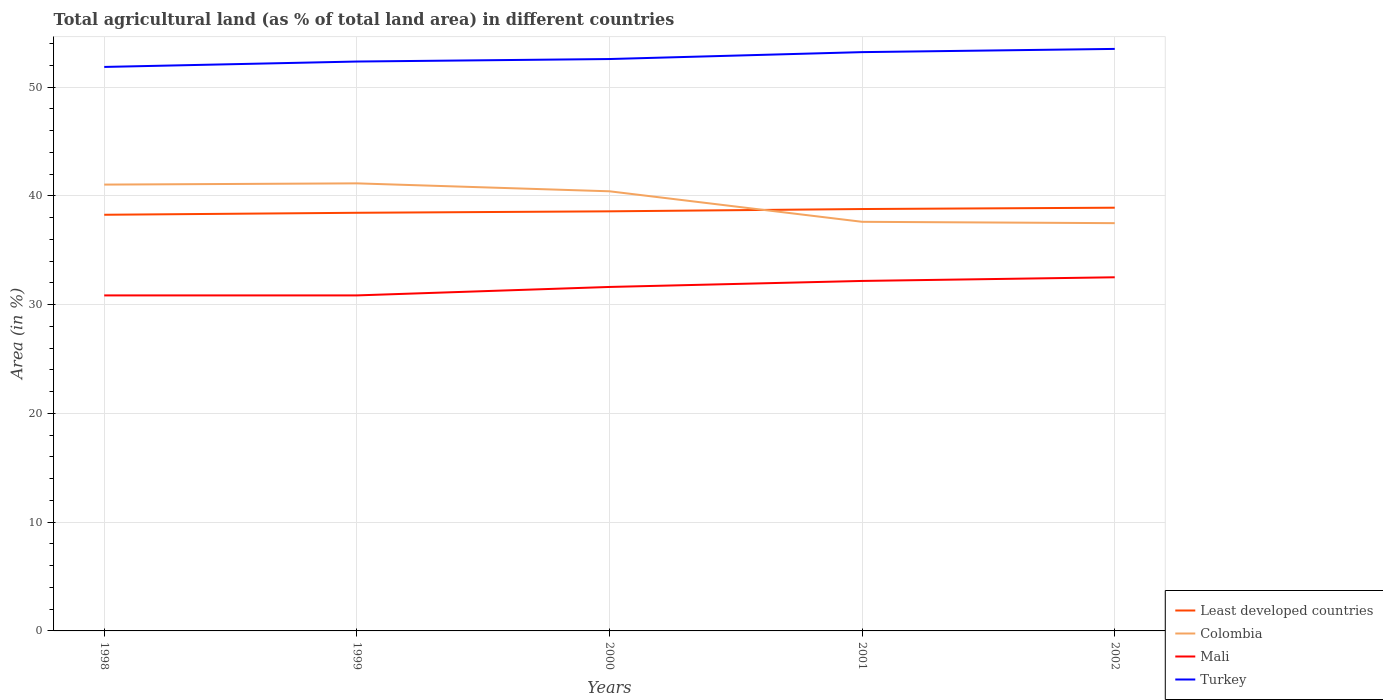Does the line corresponding to Mali intersect with the line corresponding to Least developed countries?
Your answer should be compact. No. Is the number of lines equal to the number of legend labels?
Offer a terse response. Yes. Across all years, what is the maximum percentage of agricultural land in Mali?
Your answer should be very brief. 30.86. In which year was the percentage of agricultural land in Turkey maximum?
Offer a terse response. 1998. What is the total percentage of agricultural land in Least developed countries in the graph?
Provide a succinct answer. -0.32. What is the difference between the highest and the second highest percentage of agricultural land in Least developed countries?
Offer a very short reply. 0.65. How many lines are there?
Provide a succinct answer. 4. How many years are there in the graph?
Your answer should be compact. 5. What is the difference between two consecutive major ticks on the Y-axis?
Offer a very short reply. 10. Does the graph contain any zero values?
Offer a very short reply. No. Does the graph contain grids?
Provide a succinct answer. Yes. Where does the legend appear in the graph?
Offer a very short reply. Bottom right. How many legend labels are there?
Your answer should be very brief. 4. How are the legend labels stacked?
Give a very brief answer. Vertical. What is the title of the graph?
Keep it short and to the point. Total agricultural land (as % of total land area) in different countries. What is the label or title of the Y-axis?
Offer a very short reply. Area (in %). What is the Area (in %) of Least developed countries in 1998?
Provide a short and direct response. 38.27. What is the Area (in %) of Colombia in 1998?
Offer a very short reply. 41.05. What is the Area (in %) in Mali in 1998?
Give a very brief answer. 30.86. What is the Area (in %) in Turkey in 1998?
Make the answer very short. 51.87. What is the Area (in %) of Least developed countries in 1999?
Your response must be concise. 38.46. What is the Area (in %) in Colombia in 1999?
Ensure brevity in your answer.  41.16. What is the Area (in %) in Mali in 1999?
Provide a short and direct response. 30.86. What is the Area (in %) of Turkey in 1999?
Keep it short and to the point. 52.37. What is the Area (in %) in Least developed countries in 2000?
Your answer should be compact. 38.59. What is the Area (in %) of Colombia in 2000?
Your response must be concise. 40.43. What is the Area (in %) of Mali in 2000?
Offer a very short reply. 31.63. What is the Area (in %) in Turkey in 2000?
Ensure brevity in your answer.  52.6. What is the Area (in %) in Least developed countries in 2001?
Offer a terse response. 38.8. What is the Area (in %) in Colombia in 2001?
Your answer should be very brief. 37.63. What is the Area (in %) of Mali in 2001?
Your answer should be compact. 32.19. What is the Area (in %) in Turkey in 2001?
Your response must be concise. 53.23. What is the Area (in %) in Least developed countries in 2002?
Provide a short and direct response. 38.92. What is the Area (in %) of Colombia in 2002?
Keep it short and to the point. 37.5. What is the Area (in %) in Mali in 2002?
Your answer should be compact. 32.52. What is the Area (in %) of Turkey in 2002?
Offer a terse response. 53.53. Across all years, what is the maximum Area (in %) of Least developed countries?
Offer a terse response. 38.92. Across all years, what is the maximum Area (in %) in Colombia?
Your answer should be compact. 41.16. Across all years, what is the maximum Area (in %) in Mali?
Your answer should be very brief. 32.52. Across all years, what is the maximum Area (in %) of Turkey?
Keep it short and to the point. 53.53. Across all years, what is the minimum Area (in %) of Least developed countries?
Keep it short and to the point. 38.27. Across all years, what is the minimum Area (in %) of Colombia?
Keep it short and to the point. 37.5. Across all years, what is the minimum Area (in %) of Mali?
Your response must be concise. 30.86. Across all years, what is the minimum Area (in %) in Turkey?
Your response must be concise. 51.87. What is the total Area (in %) in Least developed countries in the graph?
Give a very brief answer. 193.04. What is the total Area (in %) of Colombia in the graph?
Offer a terse response. 197.77. What is the total Area (in %) of Mali in the graph?
Your answer should be very brief. 158.06. What is the total Area (in %) of Turkey in the graph?
Offer a terse response. 263.59. What is the difference between the Area (in %) of Least developed countries in 1998 and that in 1999?
Keep it short and to the point. -0.18. What is the difference between the Area (in %) of Colombia in 1998 and that in 1999?
Provide a succinct answer. -0.11. What is the difference between the Area (in %) of Mali in 1998 and that in 1999?
Offer a very short reply. 0. What is the difference between the Area (in %) of Turkey in 1998 and that in 1999?
Your response must be concise. -0.5. What is the difference between the Area (in %) of Least developed countries in 1998 and that in 2000?
Provide a short and direct response. -0.32. What is the difference between the Area (in %) of Colombia in 1998 and that in 2000?
Ensure brevity in your answer.  0.62. What is the difference between the Area (in %) of Mali in 1998 and that in 2000?
Offer a very short reply. -0.78. What is the difference between the Area (in %) of Turkey in 1998 and that in 2000?
Keep it short and to the point. -0.73. What is the difference between the Area (in %) in Least developed countries in 1998 and that in 2001?
Your answer should be very brief. -0.53. What is the difference between the Area (in %) of Colombia in 1998 and that in 2001?
Your response must be concise. 3.42. What is the difference between the Area (in %) of Mali in 1998 and that in 2001?
Your answer should be compact. -1.33. What is the difference between the Area (in %) in Turkey in 1998 and that in 2001?
Offer a very short reply. -1.36. What is the difference between the Area (in %) of Least developed countries in 1998 and that in 2002?
Your answer should be very brief. -0.65. What is the difference between the Area (in %) of Colombia in 1998 and that in 2002?
Your answer should be very brief. 3.55. What is the difference between the Area (in %) of Mali in 1998 and that in 2002?
Offer a very short reply. -1.67. What is the difference between the Area (in %) in Turkey in 1998 and that in 2002?
Ensure brevity in your answer.  -1.66. What is the difference between the Area (in %) of Least developed countries in 1999 and that in 2000?
Give a very brief answer. -0.13. What is the difference between the Area (in %) of Colombia in 1999 and that in 2000?
Your answer should be compact. 0.73. What is the difference between the Area (in %) of Mali in 1999 and that in 2000?
Make the answer very short. -0.78. What is the difference between the Area (in %) of Turkey in 1999 and that in 2000?
Offer a terse response. -0.23. What is the difference between the Area (in %) in Least developed countries in 1999 and that in 2001?
Your response must be concise. -0.34. What is the difference between the Area (in %) in Colombia in 1999 and that in 2001?
Offer a terse response. 3.54. What is the difference between the Area (in %) of Mali in 1999 and that in 2001?
Your response must be concise. -1.33. What is the difference between the Area (in %) in Turkey in 1999 and that in 2001?
Give a very brief answer. -0.87. What is the difference between the Area (in %) of Least developed countries in 1999 and that in 2002?
Your answer should be compact. -0.47. What is the difference between the Area (in %) in Colombia in 1999 and that in 2002?
Your response must be concise. 3.66. What is the difference between the Area (in %) in Mali in 1999 and that in 2002?
Provide a succinct answer. -1.67. What is the difference between the Area (in %) of Turkey in 1999 and that in 2002?
Make the answer very short. -1.16. What is the difference between the Area (in %) of Least developed countries in 2000 and that in 2001?
Provide a succinct answer. -0.21. What is the difference between the Area (in %) in Colombia in 2000 and that in 2001?
Provide a succinct answer. 2.81. What is the difference between the Area (in %) of Mali in 2000 and that in 2001?
Provide a succinct answer. -0.55. What is the difference between the Area (in %) of Turkey in 2000 and that in 2001?
Give a very brief answer. -0.64. What is the difference between the Area (in %) in Least developed countries in 2000 and that in 2002?
Offer a very short reply. -0.33. What is the difference between the Area (in %) in Colombia in 2000 and that in 2002?
Offer a very short reply. 2.93. What is the difference between the Area (in %) in Mali in 2000 and that in 2002?
Make the answer very short. -0.89. What is the difference between the Area (in %) of Turkey in 2000 and that in 2002?
Make the answer very short. -0.93. What is the difference between the Area (in %) in Least developed countries in 2001 and that in 2002?
Ensure brevity in your answer.  -0.12. What is the difference between the Area (in %) of Colombia in 2001 and that in 2002?
Provide a short and direct response. 0.12. What is the difference between the Area (in %) of Mali in 2001 and that in 2002?
Give a very brief answer. -0.34. What is the difference between the Area (in %) in Turkey in 2001 and that in 2002?
Your answer should be very brief. -0.3. What is the difference between the Area (in %) of Least developed countries in 1998 and the Area (in %) of Colombia in 1999?
Provide a succinct answer. -2.89. What is the difference between the Area (in %) of Least developed countries in 1998 and the Area (in %) of Mali in 1999?
Your answer should be compact. 7.42. What is the difference between the Area (in %) of Least developed countries in 1998 and the Area (in %) of Turkey in 1999?
Keep it short and to the point. -14.09. What is the difference between the Area (in %) in Colombia in 1998 and the Area (in %) in Mali in 1999?
Provide a succinct answer. 10.19. What is the difference between the Area (in %) in Colombia in 1998 and the Area (in %) in Turkey in 1999?
Make the answer very short. -11.32. What is the difference between the Area (in %) in Mali in 1998 and the Area (in %) in Turkey in 1999?
Provide a short and direct response. -21.51. What is the difference between the Area (in %) in Least developed countries in 1998 and the Area (in %) in Colombia in 2000?
Your response must be concise. -2.16. What is the difference between the Area (in %) of Least developed countries in 1998 and the Area (in %) of Mali in 2000?
Keep it short and to the point. 6.64. What is the difference between the Area (in %) in Least developed countries in 1998 and the Area (in %) in Turkey in 2000?
Offer a very short reply. -14.32. What is the difference between the Area (in %) in Colombia in 1998 and the Area (in %) in Mali in 2000?
Keep it short and to the point. 9.41. What is the difference between the Area (in %) in Colombia in 1998 and the Area (in %) in Turkey in 2000?
Ensure brevity in your answer.  -11.55. What is the difference between the Area (in %) in Mali in 1998 and the Area (in %) in Turkey in 2000?
Ensure brevity in your answer.  -21.74. What is the difference between the Area (in %) of Least developed countries in 1998 and the Area (in %) of Colombia in 2001?
Give a very brief answer. 0.65. What is the difference between the Area (in %) in Least developed countries in 1998 and the Area (in %) in Mali in 2001?
Ensure brevity in your answer.  6.09. What is the difference between the Area (in %) of Least developed countries in 1998 and the Area (in %) of Turkey in 2001?
Ensure brevity in your answer.  -14.96. What is the difference between the Area (in %) of Colombia in 1998 and the Area (in %) of Mali in 2001?
Provide a succinct answer. 8.86. What is the difference between the Area (in %) of Colombia in 1998 and the Area (in %) of Turkey in 2001?
Give a very brief answer. -12.18. What is the difference between the Area (in %) of Mali in 1998 and the Area (in %) of Turkey in 2001?
Provide a short and direct response. -22.37. What is the difference between the Area (in %) of Least developed countries in 1998 and the Area (in %) of Colombia in 2002?
Offer a terse response. 0.77. What is the difference between the Area (in %) of Least developed countries in 1998 and the Area (in %) of Mali in 2002?
Your answer should be very brief. 5.75. What is the difference between the Area (in %) of Least developed countries in 1998 and the Area (in %) of Turkey in 2002?
Keep it short and to the point. -15.25. What is the difference between the Area (in %) of Colombia in 1998 and the Area (in %) of Mali in 2002?
Provide a succinct answer. 8.53. What is the difference between the Area (in %) of Colombia in 1998 and the Area (in %) of Turkey in 2002?
Provide a succinct answer. -12.48. What is the difference between the Area (in %) of Mali in 1998 and the Area (in %) of Turkey in 2002?
Make the answer very short. -22.67. What is the difference between the Area (in %) in Least developed countries in 1999 and the Area (in %) in Colombia in 2000?
Offer a terse response. -1.98. What is the difference between the Area (in %) in Least developed countries in 1999 and the Area (in %) in Mali in 2000?
Provide a succinct answer. 6.82. What is the difference between the Area (in %) of Least developed countries in 1999 and the Area (in %) of Turkey in 2000?
Keep it short and to the point. -14.14. What is the difference between the Area (in %) in Colombia in 1999 and the Area (in %) in Mali in 2000?
Your answer should be very brief. 9.53. What is the difference between the Area (in %) in Colombia in 1999 and the Area (in %) in Turkey in 2000?
Give a very brief answer. -11.43. What is the difference between the Area (in %) of Mali in 1999 and the Area (in %) of Turkey in 2000?
Keep it short and to the point. -21.74. What is the difference between the Area (in %) of Least developed countries in 1999 and the Area (in %) of Colombia in 2001?
Ensure brevity in your answer.  0.83. What is the difference between the Area (in %) in Least developed countries in 1999 and the Area (in %) in Mali in 2001?
Offer a terse response. 6.27. What is the difference between the Area (in %) in Least developed countries in 1999 and the Area (in %) in Turkey in 2001?
Offer a very short reply. -14.77. What is the difference between the Area (in %) of Colombia in 1999 and the Area (in %) of Mali in 2001?
Ensure brevity in your answer.  8.97. What is the difference between the Area (in %) in Colombia in 1999 and the Area (in %) in Turkey in 2001?
Offer a terse response. -12.07. What is the difference between the Area (in %) in Mali in 1999 and the Area (in %) in Turkey in 2001?
Give a very brief answer. -22.37. What is the difference between the Area (in %) of Least developed countries in 1999 and the Area (in %) of Colombia in 2002?
Your answer should be compact. 0.96. What is the difference between the Area (in %) in Least developed countries in 1999 and the Area (in %) in Mali in 2002?
Offer a terse response. 5.93. What is the difference between the Area (in %) in Least developed countries in 1999 and the Area (in %) in Turkey in 2002?
Your answer should be compact. -15.07. What is the difference between the Area (in %) of Colombia in 1999 and the Area (in %) of Mali in 2002?
Provide a short and direct response. 8.64. What is the difference between the Area (in %) of Colombia in 1999 and the Area (in %) of Turkey in 2002?
Provide a succinct answer. -12.37. What is the difference between the Area (in %) of Mali in 1999 and the Area (in %) of Turkey in 2002?
Keep it short and to the point. -22.67. What is the difference between the Area (in %) in Least developed countries in 2000 and the Area (in %) in Colombia in 2001?
Offer a terse response. 0.96. What is the difference between the Area (in %) in Least developed countries in 2000 and the Area (in %) in Mali in 2001?
Provide a succinct answer. 6.4. What is the difference between the Area (in %) in Least developed countries in 2000 and the Area (in %) in Turkey in 2001?
Offer a terse response. -14.64. What is the difference between the Area (in %) in Colombia in 2000 and the Area (in %) in Mali in 2001?
Provide a short and direct response. 8.24. What is the difference between the Area (in %) in Colombia in 2000 and the Area (in %) in Turkey in 2001?
Your answer should be compact. -12.8. What is the difference between the Area (in %) in Mali in 2000 and the Area (in %) in Turkey in 2001?
Ensure brevity in your answer.  -21.6. What is the difference between the Area (in %) of Least developed countries in 2000 and the Area (in %) of Colombia in 2002?
Ensure brevity in your answer.  1.09. What is the difference between the Area (in %) of Least developed countries in 2000 and the Area (in %) of Mali in 2002?
Offer a terse response. 6.07. What is the difference between the Area (in %) of Least developed countries in 2000 and the Area (in %) of Turkey in 2002?
Keep it short and to the point. -14.94. What is the difference between the Area (in %) in Colombia in 2000 and the Area (in %) in Mali in 2002?
Make the answer very short. 7.91. What is the difference between the Area (in %) in Colombia in 2000 and the Area (in %) in Turkey in 2002?
Your response must be concise. -13.1. What is the difference between the Area (in %) in Mali in 2000 and the Area (in %) in Turkey in 2002?
Make the answer very short. -21.89. What is the difference between the Area (in %) in Least developed countries in 2001 and the Area (in %) in Colombia in 2002?
Offer a terse response. 1.3. What is the difference between the Area (in %) of Least developed countries in 2001 and the Area (in %) of Mali in 2002?
Provide a succinct answer. 6.28. What is the difference between the Area (in %) in Least developed countries in 2001 and the Area (in %) in Turkey in 2002?
Provide a short and direct response. -14.73. What is the difference between the Area (in %) in Colombia in 2001 and the Area (in %) in Mali in 2002?
Your answer should be very brief. 5.1. What is the difference between the Area (in %) of Colombia in 2001 and the Area (in %) of Turkey in 2002?
Make the answer very short. -15.9. What is the difference between the Area (in %) in Mali in 2001 and the Area (in %) in Turkey in 2002?
Keep it short and to the point. -21.34. What is the average Area (in %) in Least developed countries per year?
Give a very brief answer. 38.61. What is the average Area (in %) in Colombia per year?
Ensure brevity in your answer.  39.55. What is the average Area (in %) of Mali per year?
Provide a short and direct response. 31.61. What is the average Area (in %) in Turkey per year?
Your answer should be very brief. 52.72. In the year 1998, what is the difference between the Area (in %) of Least developed countries and Area (in %) of Colombia?
Ensure brevity in your answer.  -2.78. In the year 1998, what is the difference between the Area (in %) of Least developed countries and Area (in %) of Mali?
Your answer should be very brief. 7.42. In the year 1998, what is the difference between the Area (in %) of Least developed countries and Area (in %) of Turkey?
Your response must be concise. -13.59. In the year 1998, what is the difference between the Area (in %) of Colombia and Area (in %) of Mali?
Provide a short and direct response. 10.19. In the year 1998, what is the difference between the Area (in %) in Colombia and Area (in %) in Turkey?
Keep it short and to the point. -10.82. In the year 1998, what is the difference between the Area (in %) of Mali and Area (in %) of Turkey?
Give a very brief answer. -21.01. In the year 1999, what is the difference between the Area (in %) in Least developed countries and Area (in %) in Colombia?
Keep it short and to the point. -2.71. In the year 1999, what is the difference between the Area (in %) of Least developed countries and Area (in %) of Turkey?
Provide a short and direct response. -13.91. In the year 1999, what is the difference between the Area (in %) in Colombia and Area (in %) in Mali?
Offer a terse response. 10.3. In the year 1999, what is the difference between the Area (in %) in Colombia and Area (in %) in Turkey?
Your answer should be compact. -11.2. In the year 1999, what is the difference between the Area (in %) of Mali and Area (in %) of Turkey?
Provide a succinct answer. -21.51. In the year 2000, what is the difference between the Area (in %) of Least developed countries and Area (in %) of Colombia?
Your answer should be very brief. -1.84. In the year 2000, what is the difference between the Area (in %) in Least developed countries and Area (in %) in Mali?
Give a very brief answer. 6.95. In the year 2000, what is the difference between the Area (in %) in Least developed countries and Area (in %) in Turkey?
Provide a succinct answer. -14.01. In the year 2000, what is the difference between the Area (in %) of Colombia and Area (in %) of Mali?
Offer a very short reply. 8.8. In the year 2000, what is the difference between the Area (in %) of Colombia and Area (in %) of Turkey?
Give a very brief answer. -12.16. In the year 2000, what is the difference between the Area (in %) in Mali and Area (in %) in Turkey?
Your answer should be compact. -20.96. In the year 2001, what is the difference between the Area (in %) in Least developed countries and Area (in %) in Colombia?
Provide a succinct answer. 1.17. In the year 2001, what is the difference between the Area (in %) in Least developed countries and Area (in %) in Mali?
Provide a short and direct response. 6.61. In the year 2001, what is the difference between the Area (in %) in Least developed countries and Area (in %) in Turkey?
Give a very brief answer. -14.43. In the year 2001, what is the difference between the Area (in %) of Colombia and Area (in %) of Mali?
Your answer should be very brief. 5.44. In the year 2001, what is the difference between the Area (in %) in Colombia and Area (in %) in Turkey?
Provide a succinct answer. -15.61. In the year 2001, what is the difference between the Area (in %) in Mali and Area (in %) in Turkey?
Give a very brief answer. -21.04. In the year 2002, what is the difference between the Area (in %) in Least developed countries and Area (in %) in Colombia?
Your answer should be compact. 1.42. In the year 2002, what is the difference between the Area (in %) in Least developed countries and Area (in %) in Mali?
Offer a very short reply. 6.4. In the year 2002, what is the difference between the Area (in %) of Least developed countries and Area (in %) of Turkey?
Provide a succinct answer. -14.61. In the year 2002, what is the difference between the Area (in %) in Colombia and Area (in %) in Mali?
Ensure brevity in your answer.  4.98. In the year 2002, what is the difference between the Area (in %) of Colombia and Area (in %) of Turkey?
Your answer should be very brief. -16.03. In the year 2002, what is the difference between the Area (in %) in Mali and Area (in %) in Turkey?
Your response must be concise. -21. What is the ratio of the Area (in %) in Least developed countries in 1998 to that in 1999?
Provide a short and direct response. 1. What is the ratio of the Area (in %) of Least developed countries in 1998 to that in 2000?
Your answer should be very brief. 0.99. What is the ratio of the Area (in %) in Colombia in 1998 to that in 2000?
Make the answer very short. 1.02. What is the ratio of the Area (in %) of Mali in 1998 to that in 2000?
Your answer should be very brief. 0.98. What is the ratio of the Area (in %) of Turkey in 1998 to that in 2000?
Ensure brevity in your answer.  0.99. What is the ratio of the Area (in %) in Least developed countries in 1998 to that in 2001?
Give a very brief answer. 0.99. What is the ratio of the Area (in %) of Colombia in 1998 to that in 2001?
Offer a terse response. 1.09. What is the ratio of the Area (in %) in Mali in 1998 to that in 2001?
Keep it short and to the point. 0.96. What is the ratio of the Area (in %) of Turkey in 1998 to that in 2001?
Make the answer very short. 0.97. What is the ratio of the Area (in %) in Least developed countries in 1998 to that in 2002?
Keep it short and to the point. 0.98. What is the ratio of the Area (in %) in Colombia in 1998 to that in 2002?
Make the answer very short. 1.09. What is the ratio of the Area (in %) in Mali in 1998 to that in 2002?
Make the answer very short. 0.95. What is the ratio of the Area (in %) in Mali in 1999 to that in 2000?
Keep it short and to the point. 0.98. What is the ratio of the Area (in %) of Turkey in 1999 to that in 2000?
Ensure brevity in your answer.  1. What is the ratio of the Area (in %) in Least developed countries in 1999 to that in 2001?
Give a very brief answer. 0.99. What is the ratio of the Area (in %) in Colombia in 1999 to that in 2001?
Offer a very short reply. 1.09. What is the ratio of the Area (in %) of Mali in 1999 to that in 2001?
Give a very brief answer. 0.96. What is the ratio of the Area (in %) of Turkey in 1999 to that in 2001?
Provide a succinct answer. 0.98. What is the ratio of the Area (in %) of Colombia in 1999 to that in 2002?
Provide a short and direct response. 1.1. What is the ratio of the Area (in %) in Mali in 1999 to that in 2002?
Make the answer very short. 0.95. What is the ratio of the Area (in %) of Turkey in 1999 to that in 2002?
Ensure brevity in your answer.  0.98. What is the ratio of the Area (in %) in Colombia in 2000 to that in 2001?
Offer a terse response. 1.07. What is the ratio of the Area (in %) in Mali in 2000 to that in 2001?
Offer a terse response. 0.98. What is the ratio of the Area (in %) of Turkey in 2000 to that in 2001?
Keep it short and to the point. 0.99. What is the ratio of the Area (in %) in Colombia in 2000 to that in 2002?
Ensure brevity in your answer.  1.08. What is the ratio of the Area (in %) of Mali in 2000 to that in 2002?
Provide a short and direct response. 0.97. What is the ratio of the Area (in %) in Turkey in 2000 to that in 2002?
Ensure brevity in your answer.  0.98. What is the ratio of the Area (in %) of Turkey in 2001 to that in 2002?
Offer a very short reply. 0.99. What is the difference between the highest and the second highest Area (in %) of Least developed countries?
Offer a very short reply. 0.12. What is the difference between the highest and the second highest Area (in %) of Colombia?
Keep it short and to the point. 0.11. What is the difference between the highest and the second highest Area (in %) in Mali?
Offer a terse response. 0.34. What is the difference between the highest and the second highest Area (in %) in Turkey?
Your answer should be compact. 0.3. What is the difference between the highest and the lowest Area (in %) of Least developed countries?
Provide a short and direct response. 0.65. What is the difference between the highest and the lowest Area (in %) of Colombia?
Provide a short and direct response. 3.66. What is the difference between the highest and the lowest Area (in %) in Mali?
Your response must be concise. 1.67. What is the difference between the highest and the lowest Area (in %) in Turkey?
Your answer should be compact. 1.66. 